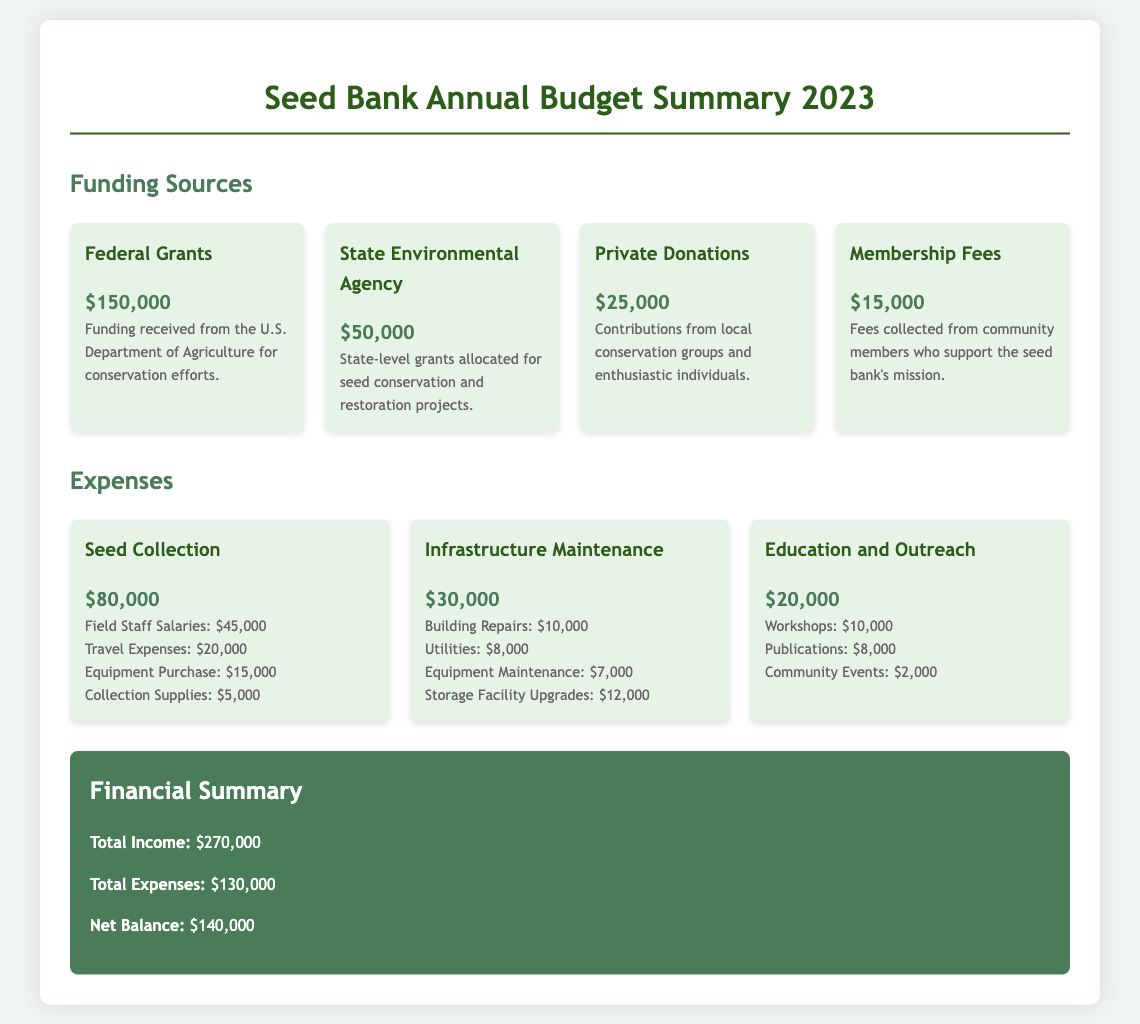What is the total income? The total income is provided in the financial summary section, which lists it as $270,000.
Answer: $270,000 How much did the seed collection expenses total? The seed collection expenses are detailed in the expenses section, totaling $80,000.
Answer: $80,000 What is the funding amount from Private Donations? The funding amount from Private Donations is specified as $25,000 in the funding sources section.
Answer: $25,000 What are the expenses for Education and Outreach? The expenses for Education and Outreach are mentioned in the expenses section, totaling $20,000.
Answer: $20,000 Which organization provided Federal Grants? The organization providing Federal Grants is the U.S. Department of Agriculture according to the funding sources section.
Answer: U.S. Department of Agriculture What is the net balance computed for the year? The net balance for the year is calculated in the financial summary as Total Income minus Total Expenses, resulting in $140,000.
Answer: $140,000 What is the amount allocated for Building Repairs? The amount allocated for Building Repairs is specified in the infrastructure maintenance expenses as $10,000.
Answer: $10,000 Which funding source has the lowest amount? The funding source with the lowest amount is Membership Fees, listed as $15,000.
Answer: Membership Fees What is the overall expenses total for the year? The overall expenses total is given in the financial summary as $130,000.
Answer: $130,000 